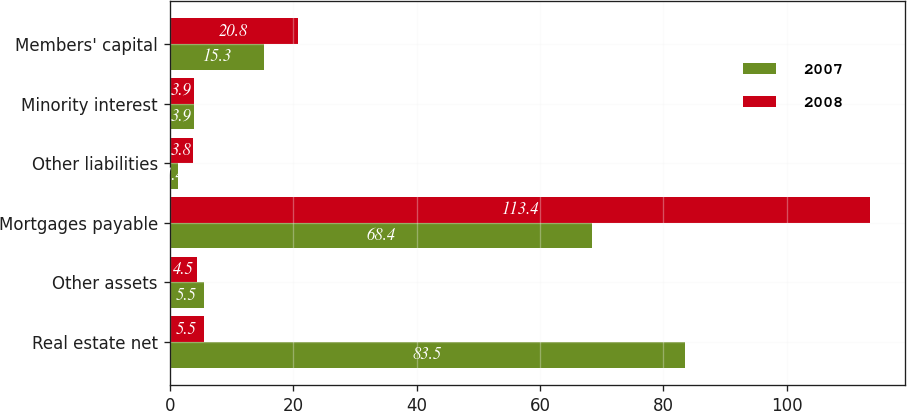Convert chart to OTSL. <chart><loc_0><loc_0><loc_500><loc_500><stacked_bar_chart><ecel><fcel>Real estate net<fcel>Other assets<fcel>Mortgages payable<fcel>Other liabilities<fcel>Minority interest<fcel>Members' capital<nl><fcel>2007<fcel>83.5<fcel>5.5<fcel>68.4<fcel>1.4<fcel>3.9<fcel>15.3<nl><fcel>2008<fcel>5.5<fcel>4.5<fcel>113.4<fcel>3.8<fcel>3.9<fcel>20.8<nl></chart> 